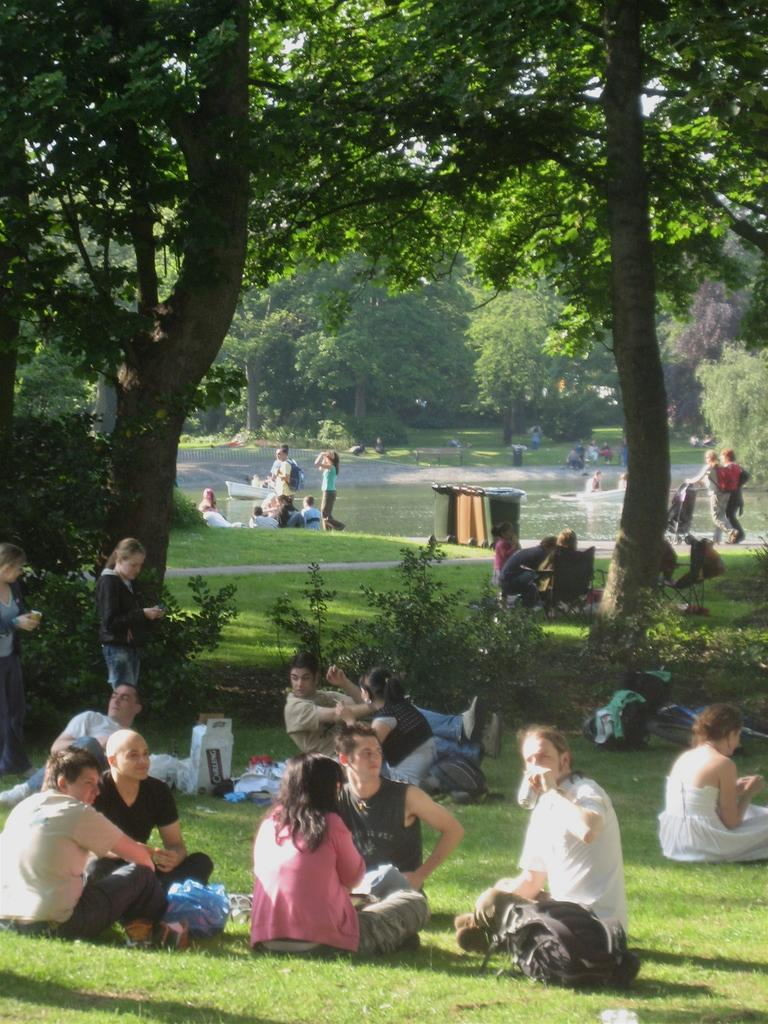What are the people in the image doing? The people in the image are in the water and on the grass. What type of environment is visible in the image? There are trees visible in the image, suggesting a natural setting. What type of trains can be seen passing by in the image? There are no trains visible in the image; it features people in the water and on the grass, with trees in the background. How many geese are present at the feast in the image? There is no feast or geese present in the image. 